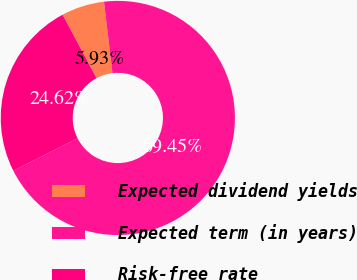<chart> <loc_0><loc_0><loc_500><loc_500><pie_chart><fcel>Expected dividend yields<fcel>Expected term (in years)<fcel>Risk-free rate<nl><fcel>5.93%<fcel>69.44%<fcel>24.62%<nl></chart> 